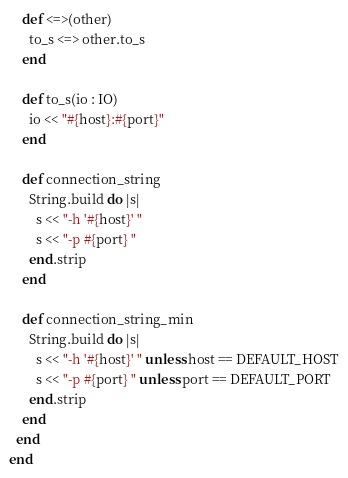Convert code to text. <code><loc_0><loc_0><loc_500><loc_500><_Crystal_>
    def <=>(other)
      to_s <=> other.to_s
    end

    def to_s(io : IO)
      io << "#{host}:#{port}"
    end

    def connection_string
      String.build do |s|
        s << "-h '#{host}' "
        s << "-p #{port} "
      end.strip
    end

    def connection_string_min
      String.build do |s|
        s << "-h '#{host}' " unless host == DEFAULT_HOST
        s << "-p #{port} " unless port == DEFAULT_PORT
      end.strip
    end
  end
end
</code> 